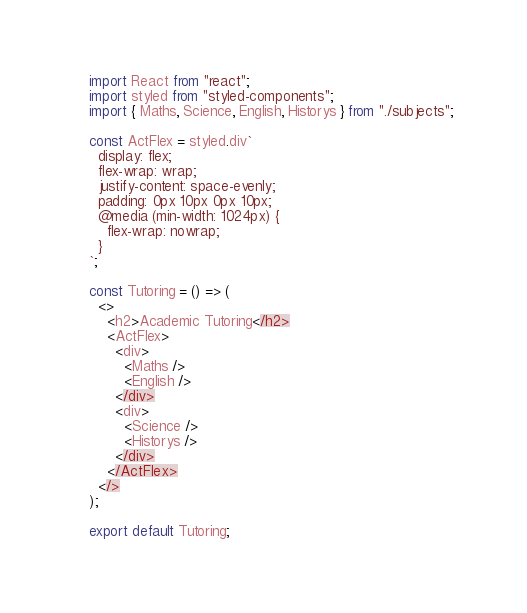Convert code to text. <code><loc_0><loc_0><loc_500><loc_500><_JavaScript_>import React from "react";
import styled from "styled-components";
import { Maths, Science, English, Historys } from "./subjects";

const ActFlex = styled.div`
  display: flex;
  flex-wrap: wrap;
  justify-content: space-evenly;
  padding: 0px 10px 0px 10px;
  @media (min-width: 1024px) {
    flex-wrap: nowrap;
  }
`;

const Tutoring = () => (
  <>
    <h2>Academic Tutoring</h2>
    <ActFlex>
      <div>
        <Maths />
        <English />
      </div>
      <div>
        <Science />
        <Historys />
      </div>
    </ActFlex>
  </>
);

export default Tutoring;
</code> 